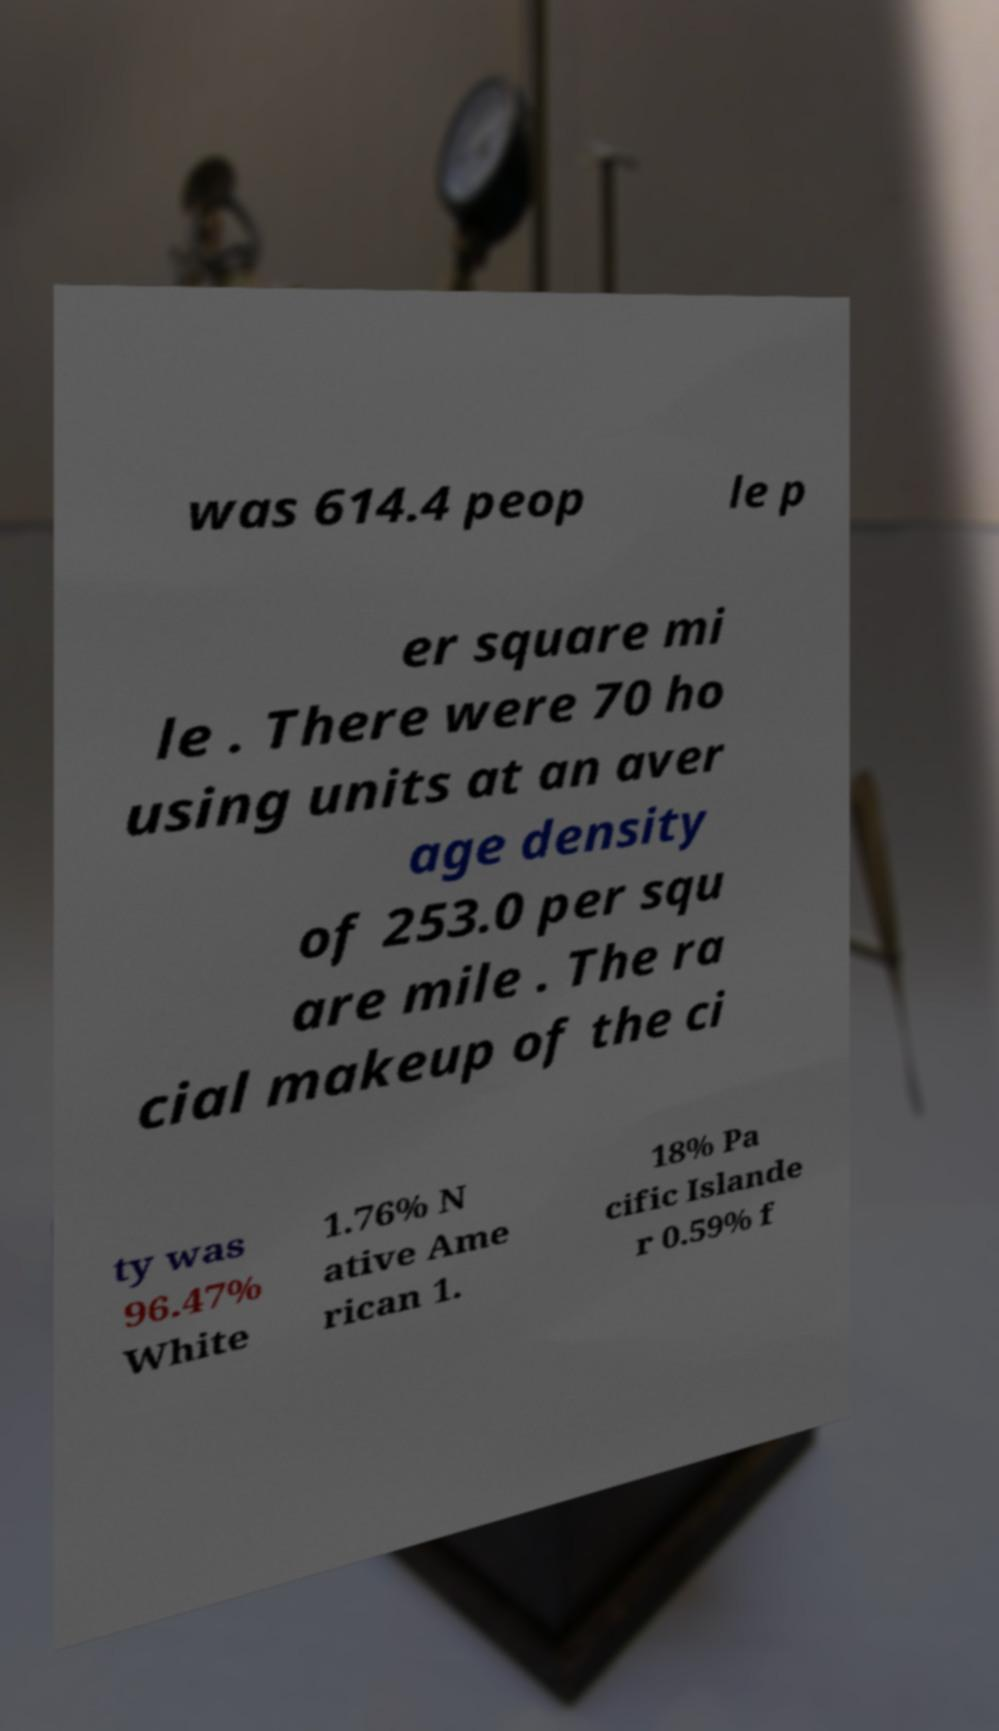For documentation purposes, I need the text within this image transcribed. Could you provide that? was 614.4 peop le p er square mi le . There were 70 ho using units at an aver age density of 253.0 per squ are mile . The ra cial makeup of the ci ty was 96.47% White 1.76% N ative Ame rican 1. 18% Pa cific Islande r 0.59% f 